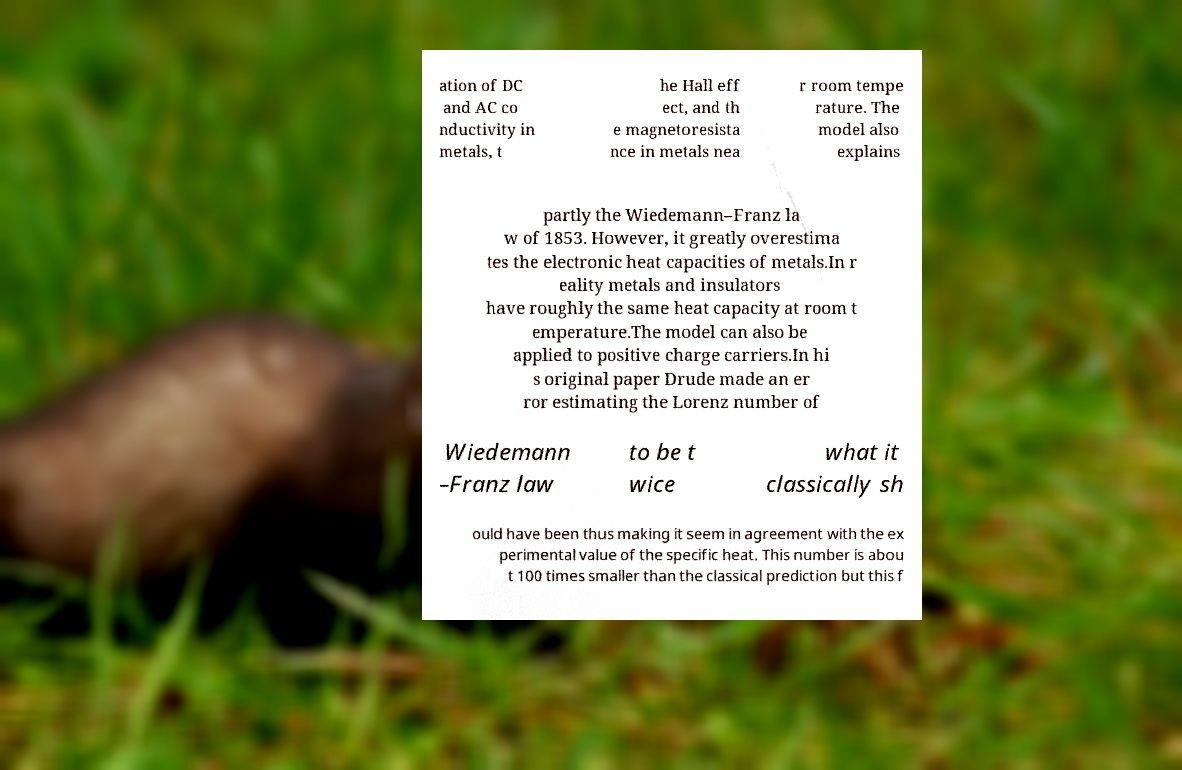For documentation purposes, I need the text within this image transcribed. Could you provide that? ation of DC and AC co nductivity in metals, t he Hall eff ect, and th e magnetoresista nce in metals nea r room tempe rature. The model also explains partly the Wiedemann–Franz la w of 1853. However, it greatly overestima tes the electronic heat capacities of metals.In r eality metals and insulators have roughly the same heat capacity at room t emperature.The model can also be applied to positive charge carriers.In hi s original paper Drude made an er ror estimating the Lorenz number of Wiedemann –Franz law to be t wice what it classically sh ould have been thus making it seem in agreement with the ex perimental value of the specific heat. This number is abou t 100 times smaller than the classical prediction but this f 